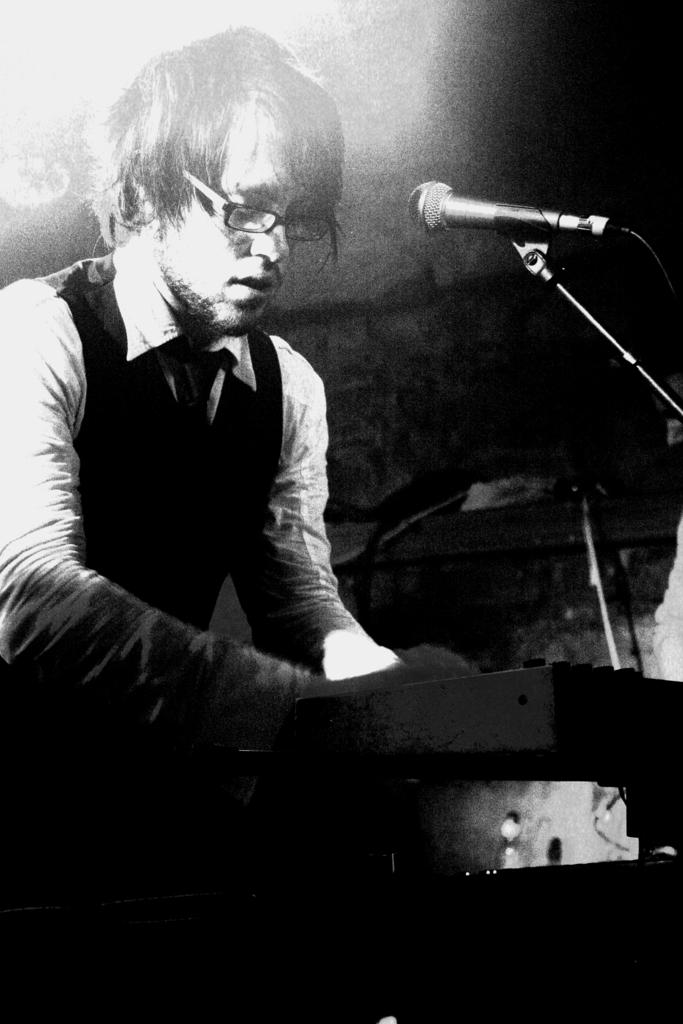Who is the main subject in the image? There is a man in the image. What is the man wearing? The man is wearing spectacles. What is the man standing in front of? The man is standing in front of a mic. What type of garden can be seen in the background of the image? There is no garden present in the image; it features a man standing in front of a mic. What musical instrument is the man playing in the image? The image does not show the man playing any musical instrument. 